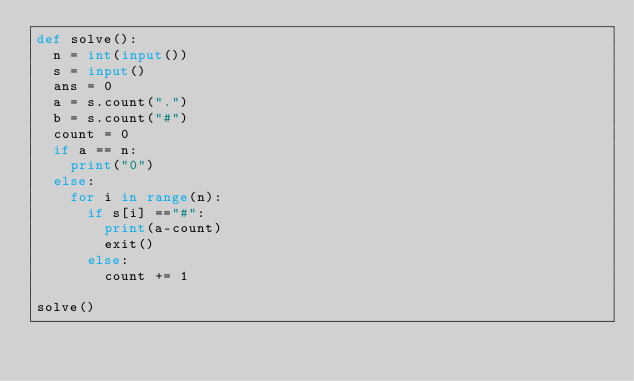<code> <loc_0><loc_0><loc_500><loc_500><_Python_>def solve():
  n = int(input())
  s = input()
  ans = 0
  a = s.count(".")
  b = s.count("#")
  count = 0
  if a == n:
    print("0")
  else:
    for i in range(n):
      if s[i] =="#":
        print(a-count)
        exit()
      else:
        count += 1
        
solve()</code> 